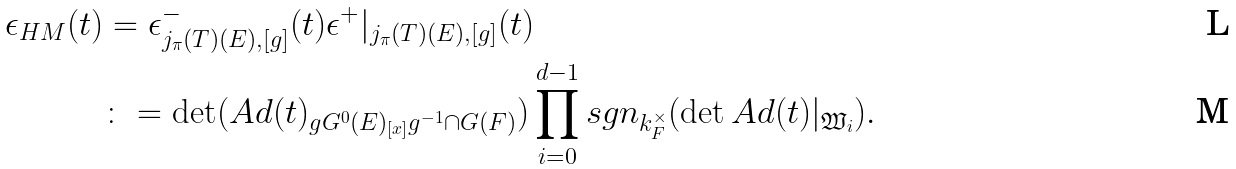<formula> <loc_0><loc_0><loc_500><loc_500>\epsilon _ { H M } ( t ) & = \epsilon ^ { - } _ { j _ { \pi } ( T ) ( E ) , [ g ] } ( t ) \epsilon ^ { + } | _ { j _ { \pi } ( T ) ( E ) , [ g ] } ( t ) \\ & \colon = \det ( A d ( t ) _ { g G ^ { 0 } ( E ) _ { [ x ] } g ^ { - 1 } \cap G ( F ) } ) \prod _ { i = 0 } ^ { d - 1 } s g n _ { k _ { F } ^ { \times } } ( \det A d ( t ) | _ { \mathfrak { W } _ { i } } ) .</formula> 